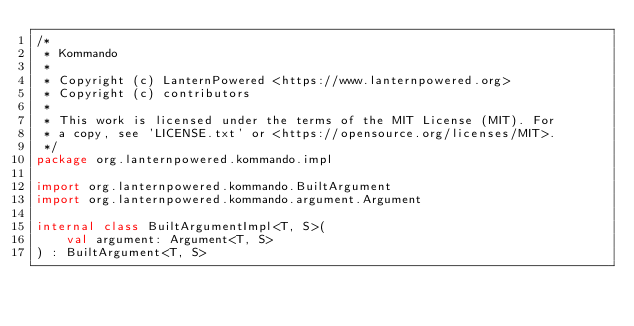Convert code to text. <code><loc_0><loc_0><loc_500><loc_500><_Kotlin_>/*
 * Kommando
 *
 * Copyright (c) LanternPowered <https://www.lanternpowered.org>
 * Copyright (c) contributors
 *
 * This work is licensed under the terms of the MIT License (MIT). For
 * a copy, see 'LICENSE.txt' or <https://opensource.org/licenses/MIT>.
 */
package org.lanternpowered.kommando.impl

import org.lanternpowered.kommando.BuiltArgument
import org.lanternpowered.kommando.argument.Argument

internal class BuiltArgumentImpl<T, S>(
    val argument: Argument<T, S>
) : BuiltArgument<T, S>
</code> 